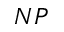Convert formula to latex. <formula><loc_0><loc_0><loc_500><loc_500>N P</formula> 